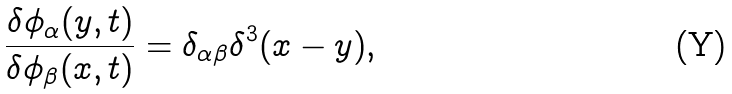<formula> <loc_0><loc_0><loc_500><loc_500>\frac { \delta \phi _ { \alpha } ( y , t ) } { \delta \phi _ { \beta } ( x , t ) } = \delta _ { \alpha \beta } \delta ^ { 3 } ( x - y ) ,</formula> 